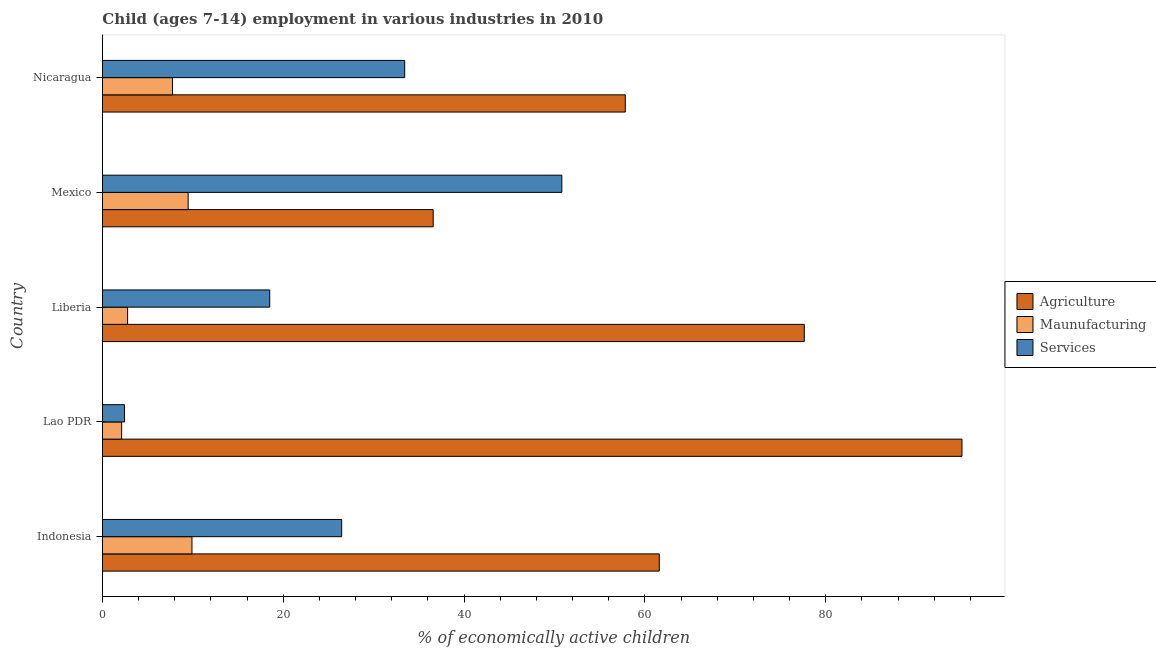How many groups of bars are there?
Give a very brief answer. 5. Are the number of bars per tick equal to the number of legend labels?
Keep it short and to the point. Yes. Are the number of bars on each tick of the Y-axis equal?
Provide a short and direct response. Yes. How many bars are there on the 5th tick from the bottom?
Provide a succinct answer. 3. What is the label of the 4th group of bars from the top?
Make the answer very short. Lao PDR. What is the percentage of economically active children in agriculture in Nicaragua?
Ensure brevity in your answer.  57.83. Across all countries, what is the maximum percentage of economically active children in services?
Offer a very short reply. 50.81. Across all countries, what is the minimum percentage of economically active children in manufacturing?
Your answer should be compact. 2.12. What is the total percentage of economically active children in services in the graph?
Offer a terse response. 131.64. What is the difference between the percentage of economically active children in services in Mexico and that in Nicaragua?
Give a very brief answer. 17.38. What is the difference between the percentage of economically active children in services in Mexico and the percentage of economically active children in manufacturing in Indonesia?
Ensure brevity in your answer.  40.91. What is the average percentage of economically active children in manufacturing per country?
Keep it short and to the point. 6.41. What is the difference between the percentage of economically active children in services and percentage of economically active children in manufacturing in Mexico?
Your answer should be very brief. 41.33. What is the ratio of the percentage of economically active children in agriculture in Liberia to that in Mexico?
Offer a terse response. 2.12. Is the percentage of economically active children in services in Mexico less than that in Nicaragua?
Your response must be concise. No. Is the difference between the percentage of economically active children in services in Indonesia and Nicaragua greater than the difference between the percentage of economically active children in manufacturing in Indonesia and Nicaragua?
Offer a terse response. No. What is the difference between the highest and the second highest percentage of economically active children in agriculture?
Give a very brief answer. 17.44. What is the difference between the highest and the lowest percentage of economically active children in services?
Ensure brevity in your answer.  48.37. In how many countries, is the percentage of economically active children in agriculture greater than the average percentage of economically active children in agriculture taken over all countries?
Ensure brevity in your answer.  2. Is the sum of the percentage of economically active children in agriculture in Lao PDR and Liberia greater than the maximum percentage of economically active children in services across all countries?
Provide a short and direct response. Yes. What does the 2nd bar from the top in Indonesia represents?
Give a very brief answer. Maunufacturing. What does the 2nd bar from the bottom in Lao PDR represents?
Keep it short and to the point. Maunufacturing. Is it the case that in every country, the sum of the percentage of economically active children in agriculture and percentage of economically active children in manufacturing is greater than the percentage of economically active children in services?
Give a very brief answer. No. How many bars are there?
Your answer should be compact. 15. How many countries are there in the graph?
Make the answer very short. 5. What is the difference between two consecutive major ticks on the X-axis?
Your response must be concise. 20. Are the values on the major ticks of X-axis written in scientific E-notation?
Ensure brevity in your answer.  No. Does the graph contain grids?
Provide a succinct answer. No. What is the title of the graph?
Provide a short and direct response. Child (ages 7-14) employment in various industries in 2010. Does "Errors" appear as one of the legend labels in the graph?
Ensure brevity in your answer.  No. What is the label or title of the X-axis?
Keep it short and to the point. % of economically active children. What is the % of economically active children of Agriculture in Indonesia?
Your answer should be very brief. 61.59. What is the % of economically active children in Services in Indonesia?
Make the answer very short. 26.46. What is the % of economically active children in Agriculture in Lao PDR?
Provide a succinct answer. 95.07. What is the % of economically active children of Maunufacturing in Lao PDR?
Give a very brief answer. 2.12. What is the % of economically active children of Services in Lao PDR?
Offer a very short reply. 2.44. What is the % of economically active children in Agriculture in Liberia?
Provide a succinct answer. 77.63. What is the % of economically active children in Maunufacturing in Liberia?
Make the answer very short. 2.78. What is the % of economically active children of Agriculture in Mexico?
Your answer should be very brief. 36.58. What is the % of economically active children of Maunufacturing in Mexico?
Make the answer very short. 9.48. What is the % of economically active children in Services in Mexico?
Provide a succinct answer. 50.81. What is the % of economically active children in Agriculture in Nicaragua?
Your answer should be very brief. 57.83. What is the % of economically active children in Maunufacturing in Nicaragua?
Ensure brevity in your answer.  7.75. What is the % of economically active children in Services in Nicaragua?
Provide a succinct answer. 33.43. Across all countries, what is the maximum % of economically active children of Agriculture?
Ensure brevity in your answer.  95.07. Across all countries, what is the maximum % of economically active children of Maunufacturing?
Provide a succinct answer. 9.9. Across all countries, what is the maximum % of economically active children in Services?
Provide a short and direct response. 50.81. Across all countries, what is the minimum % of economically active children of Agriculture?
Offer a terse response. 36.58. Across all countries, what is the minimum % of economically active children of Maunufacturing?
Give a very brief answer. 2.12. Across all countries, what is the minimum % of economically active children of Services?
Make the answer very short. 2.44. What is the total % of economically active children in Agriculture in the graph?
Your answer should be compact. 328.7. What is the total % of economically active children of Maunufacturing in the graph?
Keep it short and to the point. 32.03. What is the total % of economically active children in Services in the graph?
Your response must be concise. 131.64. What is the difference between the % of economically active children in Agriculture in Indonesia and that in Lao PDR?
Your answer should be compact. -33.48. What is the difference between the % of economically active children in Maunufacturing in Indonesia and that in Lao PDR?
Make the answer very short. 7.78. What is the difference between the % of economically active children of Services in Indonesia and that in Lao PDR?
Offer a very short reply. 24.02. What is the difference between the % of economically active children in Agriculture in Indonesia and that in Liberia?
Keep it short and to the point. -16.04. What is the difference between the % of economically active children of Maunufacturing in Indonesia and that in Liberia?
Your answer should be compact. 7.12. What is the difference between the % of economically active children in Services in Indonesia and that in Liberia?
Your answer should be very brief. 7.96. What is the difference between the % of economically active children of Agriculture in Indonesia and that in Mexico?
Provide a succinct answer. 25.01. What is the difference between the % of economically active children in Maunufacturing in Indonesia and that in Mexico?
Keep it short and to the point. 0.42. What is the difference between the % of economically active children in Services in Indonesia and that in Mexico?
Ensure brevity in your answer.  -24.35. What is the difference between the % of economically active children in Agriculture in Indonesia and that in Nicaragua?
Make the answer very short. 3.76. What is the difference between the % of economically active children in Maunufacturing in Indonesia and that in Nicaragua?
Make the answer very short. 2.15. What is the difference between the % of economically active children in Services in Indonesia and that in Nicaragua?
Your answer should be very brief. -6.97. What is the difference between the % of economically active children of Agriculture in Lao PDR and that in Liberia?
Your response must be concise. 17.44. What is the difference between the % of economically active children in Maunufacturing in Lao PDR and that in Liberia?
Keep it short and to the point. -0.66. What is the difference between the % of economically active children in Services in Lao PDR and that in Liberia?
Make the answer very short. -16.06. What is the difference between the % of economically active children in Agriculture in Lao PDR and that in Mexico?
Offer a terse response. 58.49. What is the difference between the % of economically active children of Maunufacturing in Lao PDR and that in Mexico?
Keep it short and to the point. -7.36. What is the difference between the % of economically active children of Services in Lao PDR and that in Mexico?
Offer a terse response. -48.37. What is the difference between the % of economically active children in Agriculture in Lao PDR and that in Nicaragua?
Offer a terse response. 37.24. What is the difference between the % of economically active children in Maunufacturing in Lao PDR and that in Nicaragua?
Ensure brevity in your answer.  -5.63. What is the difference between the % of economically active children of Services in Lao PDR and that in Nicaragua?
Your response must be concise. -30.99. What is the difference between the % of economically active children of Agriculture in Liberia and that in Mexico?
Offer a very short reply. 41.05. What is the difference between the % of economically active children of Maunufacturing in Liberia and that in Mexico?
Provide a short and direct response. -6.7. What is the difference between the % of economically active children of Services in Liberia and that in Mexico?
Keep it short and to the point. -32.31. What is the difference between the % of economically active children of Agriculture in Liberia and that in Nicaragua?
Your answer should be very brief. 19.8. What is the difference between the % of economically active children in Maunufacturing in Liberia and that in Nicaragua?
Provide a succinct answer. -4.97. What is the difference between the % of economically active children in Services in Liberia and that in Nicaragua?
Offer a very short reply. -14.93. What is the difference between the % of economically active children in Agriculture in Mexico and that in Nicaragua?
Give a very brief answer. -21.25. What is the difference between the % of economically active children of Maunufacturing in Mexico and that in Nicaragua?
Your response must be concise. 1.73. What is the difference between the % of economically active children in Services in Mexico and that in Nicaragua?
Ensure brevity in your answer.  17.38. What is the difference between the % of economically active children in Agriculture in Indonesia and the % of economically active children in Maunufacturing in Lao PDR?
Provide a succinct answer. 59.47. What is the difference between the % of economically active children in Agriculture in Indonesia and the % of economically active children in Services in Lao PDR?
Provide a short and direct response. 59.15. What is the difference between the % of economically active children of Maunufacturing in Indonesia and the % of economically active children of Services in Lao PDR?
Your answer should be very brief. 7.46. What is the difference between the % of economically active children of Agriculture in Indonesia and the % of economically active children of Maunufacturing in Liberia?
Give a very brief answer. 58.81. What is the difference between the % of economically active children of Agriculture in Indonesia and the % of economically active children of Services in Liberia?
Make the answer very short. 43.09. What is the difference between the % of economically active children of Maunufacturing in Indonesia and the % of economically active children of Services in Liberia?
Ensure brevity in your answer.  -8.6. What is the difference between the % of economically active children of Agriculture in Indonesia and the % of economically active children of Maunufacturing in Mexico?
Make the answer very short. 52.11. What is the difference between the % of economically active children in Agriculture in Indonesia and the % of economically active children in Services in Mexico?
Your answer should be compact. 10.78. What is the difference between the % of economically active children of Maunufacturing in Indonesia and the % of economically active children of Services in Mexico?
Give a very brief answer. -40.91. What is the difference between the % of economically active children in Agriculture in Indonesia and the % of economically active children in Maunufacturing in Nicaragua?
Give a very brief answer. 53.84. What is the difference between the % of economically active children in Agriculture in Indonesia and the % of economically active children in Services in Nicaragua?
Your answer should be very brief. 28.16. What is the difference between the % of economically active children in Maunufacturing in Indonesia and the % of economically active children in Services in Nicaragua?
Keep it short and to the point. -23.53. What is the difference between the % of economically active children in Agriculture in Lao PDR and the % of economically active children in Maunufacturing in Liberia?
Your answer should be very brief. 92.29. What is the difference between the % of economically active children in Agriculture in Lao PDR and the % of economically active children in Services in Liberia?
Ensure brevity in your answer.  76.57. What is the difference between the % of economically active children in Maunufacturing in Lao PDR and the % of economically active children in Services in Liberia?
Provide a short and direct response. -16.38. What is the difference between the % of economically active children in Agriculture in Lao PDR and the % of economically active children in Maunufacturing in Mexico?
Keep it short and to the point. 85.59. What is the difference between the % of economically active children in Agriculture in Lao PDR and the % of economically active children in Services in Mexico?
Give a very brief answer. 44.26. What is the difference between the % of economically active children of Maunufacturing in Lao PDR and the % of economically active children of Services in Mexico?
Keep it short and to the point. -48.69. What is the difference between the % of economically active children of Agriculture in Lao PDR and the % of economically active children of Maunufacturing in Nicaragua?
Make the answer very short. 87.32. What is the difference between the % of economically active children of Agriculture in Lao PDR and the % of economically active children of Services in Nicaragua?
Provide a short and direct response. 61.64. What is the difference between the % of economically active children of Maunufacturing in Lao PDR and the % of economically active children of Services in Nicaragua?
Provide a short and direct response. -31.31. What is the difference between the % of economically active children of Agriculture in Liberia and the % of economically active children of Maunufacturing in Mexico?
Your answer should be very brief. 68.15. What is the difference between the % of economically active children of Agriculture in Liberia and the % of economically active children of Services in Mexico?
Your answer should be compact. 26.82. What is the difference between the % of economically active children of Maunufacturing in Liberia and the % of economically active children of Services in Mexico?
Make the answer very short. -48.03. What is the difference between the % of economically active children of Agriculture in Liberia and the % of economically active children of Maunufacturing in Nicaragua?
Keep it short and to the point. 69.88. What is the difference between the % of economically active children of Agriculture in Liberia and the % of economically active children of Services in Nicaragua?
Your answer should be very brief. 44.2. What is the difference between the % of economically active children of Maunufacturing in Liberia and the % of economically active children of Services in Nicaragua?
Offer a terse response. -30.65. What is the difference between the % of economically active children in Agriculture in Mexico and the % of economically active children in Maunufacturing in Nicaragua?
Provide a succinct answer. 28.83. What is the difference between the % of economically active children of Agriculture in Mexico and the % of economically active children of Services in Nicaragua?
Keep it short and to the point. 3.15. What is the difference between the % of economically active children of Maunufacturing in Mexico and the % of economically active children of Services in Nicaragua?
Your answer should be compact. -23.95. What is the average % of economically active children in Agriculture per country?
Your response must be concise. 65.74. What is the average % of economically active children of Maunufacturing per country?
Make the answer very short. 6.41. What is the average % of economically active children of Services per country?
Offer a terse response. 26.33. What is the difference between the % of economically active children of Agriculture and % of economically active children of Maunufacturing in Indonesia?
Make the answer very short. 51.69. What is the difference between the % of economically active children in Agriculture and % of economically active children in Services in Indonesia?
Offer a very short reply. 35.13. What is the difference between the % of economically active children in Maunufacturing and % of economically active children in Services in Indonesia?
Offer a very short reply. -16.56. What is the difference between the % of economically active children in Agriculture and % of economically active children in Maunufacturing in Lao PDR?
Offer a terse response. 92.95. What is the difference between the % of economically active children of Agriculture and % of economically active children of Services in Lao PDR?
Your answer should be very brief. 92.63. What is the difference between the % of economically active children in Maunufacturing and % of economically active children in Services in Lao PDR?
Provide a short and direct response. -0.32. What is the difference between the % of economically active children in Agriculture and % of economically active children in Maunufacturing in Liberia?
Provide a succinct answer. 74.85. What is the difference between the % of economically active children of Agriculture and % of economically active children of Services in Liberia?
Your answer should be compact. 59.13. What is the difference between the % of economically active children of Maunufacturing and % of economically active children of Services in Liberia?
Give a very brief answer. -15.72. What is the difference between the % of economically active children of Agriculture and % of economically active children of Maunufacturing in Mexico?
Provide a short and direct response. 27.1. What is the difference between the % of economically active children of Agriculture and % of economically active children of Services in Mexico?
Give a very brief answer. -14.23. What is the difference between the % of economically active children of Maunufacturing and % of economically active children of Services in Mexico?
Provide a succinct answer. -41.33. What is the difference between the % of economically active children in Agriculture and % of economically active children in Maunufacturing in Nicaragua?
Provide a short and direct response. 50.08. What is the difference between the % of economically active children of Agriculture and % of economically active children of Services in Nicaragua?
Give a very brief answer. 24.4. What is the difference between the % of economically active children of Maunufacturing and % of economically active children of Services in Nicaragua?
Make the answer very short. -25.68. What is the ratio of the % of economically active children of Agriculture in Indonesia to that in Lao PDR?
Provide a short and direct response. 0.65. What is the ratio of the % of economically active children in Maunufacturing in Indonesia to that in Lao PDR?
Offer a terse response. 4.67. What is the ratio of the % of economically active children of Services in Indonesia to that in Lao PDR?
Make the answer very short. 10.84. What is the ratio of the % of economically active children in Agriculture in Indonesia to that in Liberia?
Ensure brevity in your answer.  0.79. What is the ratio of the % of economically active children of Maunufacturing in Indonesia to that in Liberia?
Make the answer very short. 3.56. What is the ratio of the % of economically active children of Services in Indonesia to that in Liberia?
Give a very brief answer. 1.43. What is the ratio of the % of economically active children of Agriculture in Indonesia to that in Mexico?
Make the answer very short. 1.68. What is the ratio of the % of economically active children in Maunufacturing in Indonesia to that in Mexico?
Keep it short and to the point. 1.04. What is the ratio of the % of economically active children of Services in Indonesia to that in Mexico?
Provide a short and direct response. 0.52. What is the ratio of the % of economically active children in Agriculture in Indonesia to that in Nicaragua?
Offer a terse response. 1.06. What is the ratio of the % of economically active children of Maunufacturing in Indonesia to that in Nicaragua?
Your answer should be very brief. 1.28. What is the ratio of the % of economically active children of Services in Indonesia to that in Nicaragua?
Your response must be concise. 0.79. What is the ratio of the % of economically active children in Agriculture in Lao PDR to that in Liberia?
Offer a very short reply. 1.22. What is the ratio of the % of economically active children in Maunufacturing in Lao PDR to that in Liberia?
Give a very brief answer. 0.76. What is the ratio of the % of economically active children in Services in Lao PDR to that in Liberia?
Provide a succinct answer. 0.13. What is the ratio of the % of economically active children of Agriculture in Lao PDR to that in Mexico?
Provide a succinct answer. 2.6. What is the ratio of the % of economically active children in Maunufacturing in Lao PDR to that in Mexico?
Offer a terse response. 0.22. What is the ratio of the % of economically active children of Services in Lao PDR to that in Mexico?
Your answer should be very brief. 0.05. What is the ratio of the % of economically active children in Agriculture in Lao PDR to that in Nicaragua?
Keep it short and to the point. 1.64. What is the ratio of the % of economically active children of Maunufacturing in Lao PDR to that in Nicaragua?
Keep it short and to the point. 0.27. What is the ratio of the % of economically active children of Services in Lao PDR to that in Nicaragua?
Make the answer very short. 0.07. What is the ratio of the % of economically active children of Agriculture in Liberia to that in Mexico?
Keep it short and to the point. 2.12. What is the ratio of the % of economically active children in Maunufacturing in Liberia to that in Mexico?
Make the answer very short. 0.29. What is the ratio of the % of economically active children of Services in Liberia to that in Mexico?
Your answer should be very brief. 0.36. What is the ratio of the % of economically active children in Agriculture in Liberia to that in Nicaragua?
Offer a terse response. 1.34. What is the ratio of the % of economically active children in Maunufacturing in Liberia to that in Nicaragua?
Give a very brief answer. 0.36. What is the ratio of the % of economically active children in Services in Liberia to that in Nicaragua?
Provide a short and direct response. 0.55. What is the ratio of the % of economically active children in Agriculture in Mexico to that in Nicaragua?
Give a very brief answer. 0.63. What is the ratio of the % of economically active children of Maunufacturing in Mexico to that in Nicaragua?
Give a very brief answer. 1.22. What is the ratio of the % of economically active children in Services in Mexico to that in Nicaragua?
Keep it short and to the point. 1.52. What is the difference between the highest and the second highest % of economically active children in Agriculture?
Your answer should be very brief. 17.44. What is the difference between the highest and the second highest % of economically active children of Maunufacturing?
Keep it short and to the point. 0.42. What is the difference between the highest and the second highest % of economically active children in Services?
Offer a terse response. 17.38. What is the difference between the highest and the lowest % of economically active children in Agriculture?
Give a very brief answer. 58.49. What is the difference between the highest and the lowest % of economically active children in Maunufacturing?
Give a very brief answer. 7.78. What is the difference between the highest and the lowest % of economically active children in Services?
Give a very brief answer. 48.37. 